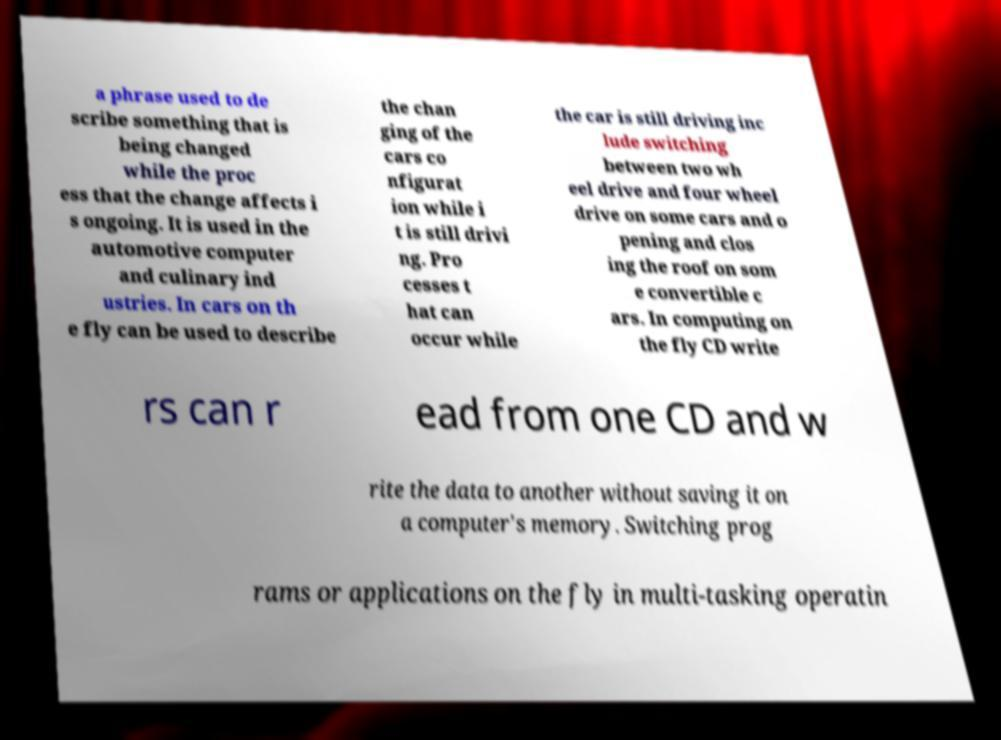Please read and relay the text visible in this image. What does it say? a phrase used to de scribe something that is being changed while the proc ess that the change affects i s ongoing. It is used in the automotive computer and culinary ind ustries. In cars on th e fly can be used to describe the chan ging of the cars co nfigurat ion while i t is still drivi ng. Pro cesses t hat can occur while the car is still driving inc lude switching between two wh eel drive and four wheel drive on some cars and o pening and clos ing the roof on som e convertible c ars. In computing on the fly CD write rs can r ead from one CD and w rite the data to another without saving it on a computer's memory. Switching prog rams or applications on the fly in multi-tasking operatin 